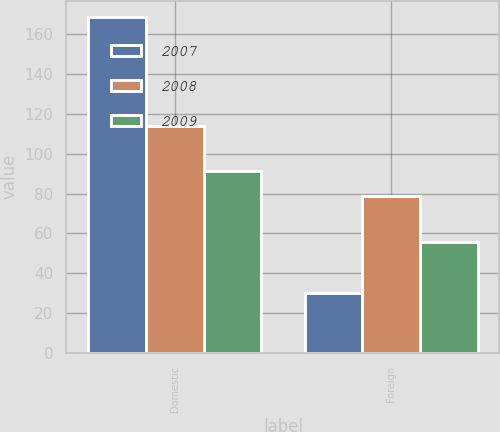<chart> <loc_0><loc_0><loc_500><loc_500><stacked_bar_chart><ecel><fcel>Domestic<fcel>Foreign<nl><fcel>2007<fcel>168.4<fcel>30<nl><fcel>2008<fcel>113.9<fcel>78.7<nl><fcel>2009<fcel>91.4<fcel>55.9<nl></chart> 